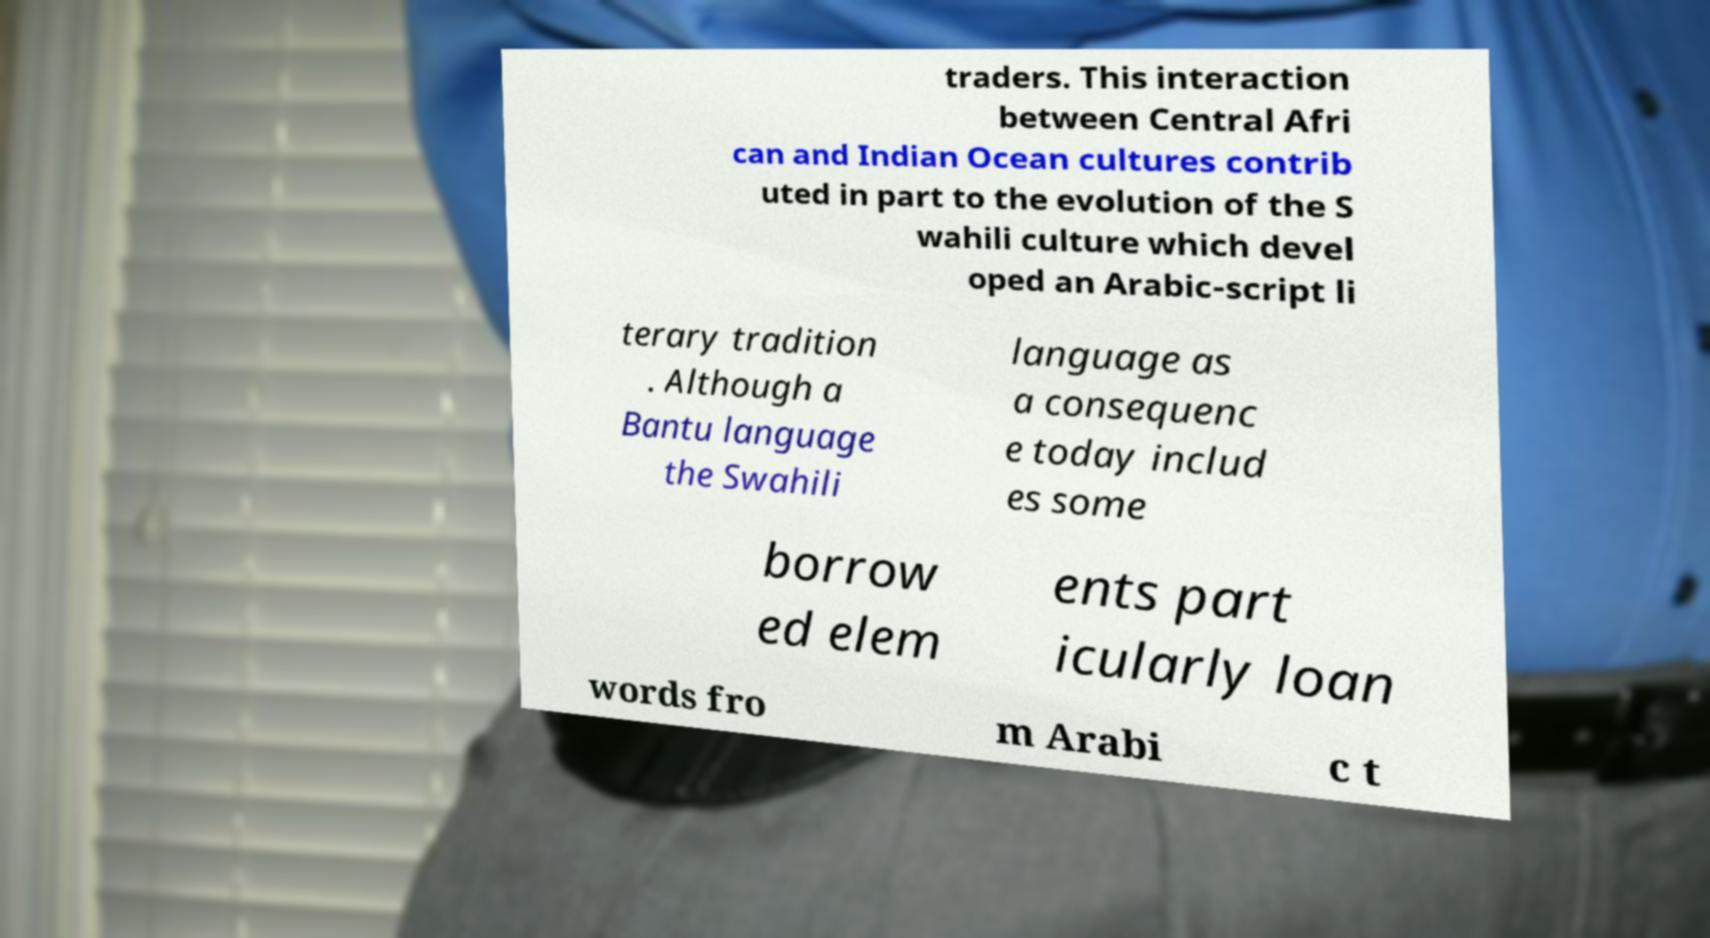What messages or text are displayed in this image? I need them in a readable, typed format. traders. This interaction between Central Afri can and Indian Ocean cultures contrib uted in part to the evolution of the S wahili culture which devel oped an Arabic-script li terary tradition . Although a Bantu language the Swahili language as a consequenc e today includ es some borrow ed elem ents part icularly loan words fro m Arabi c t 